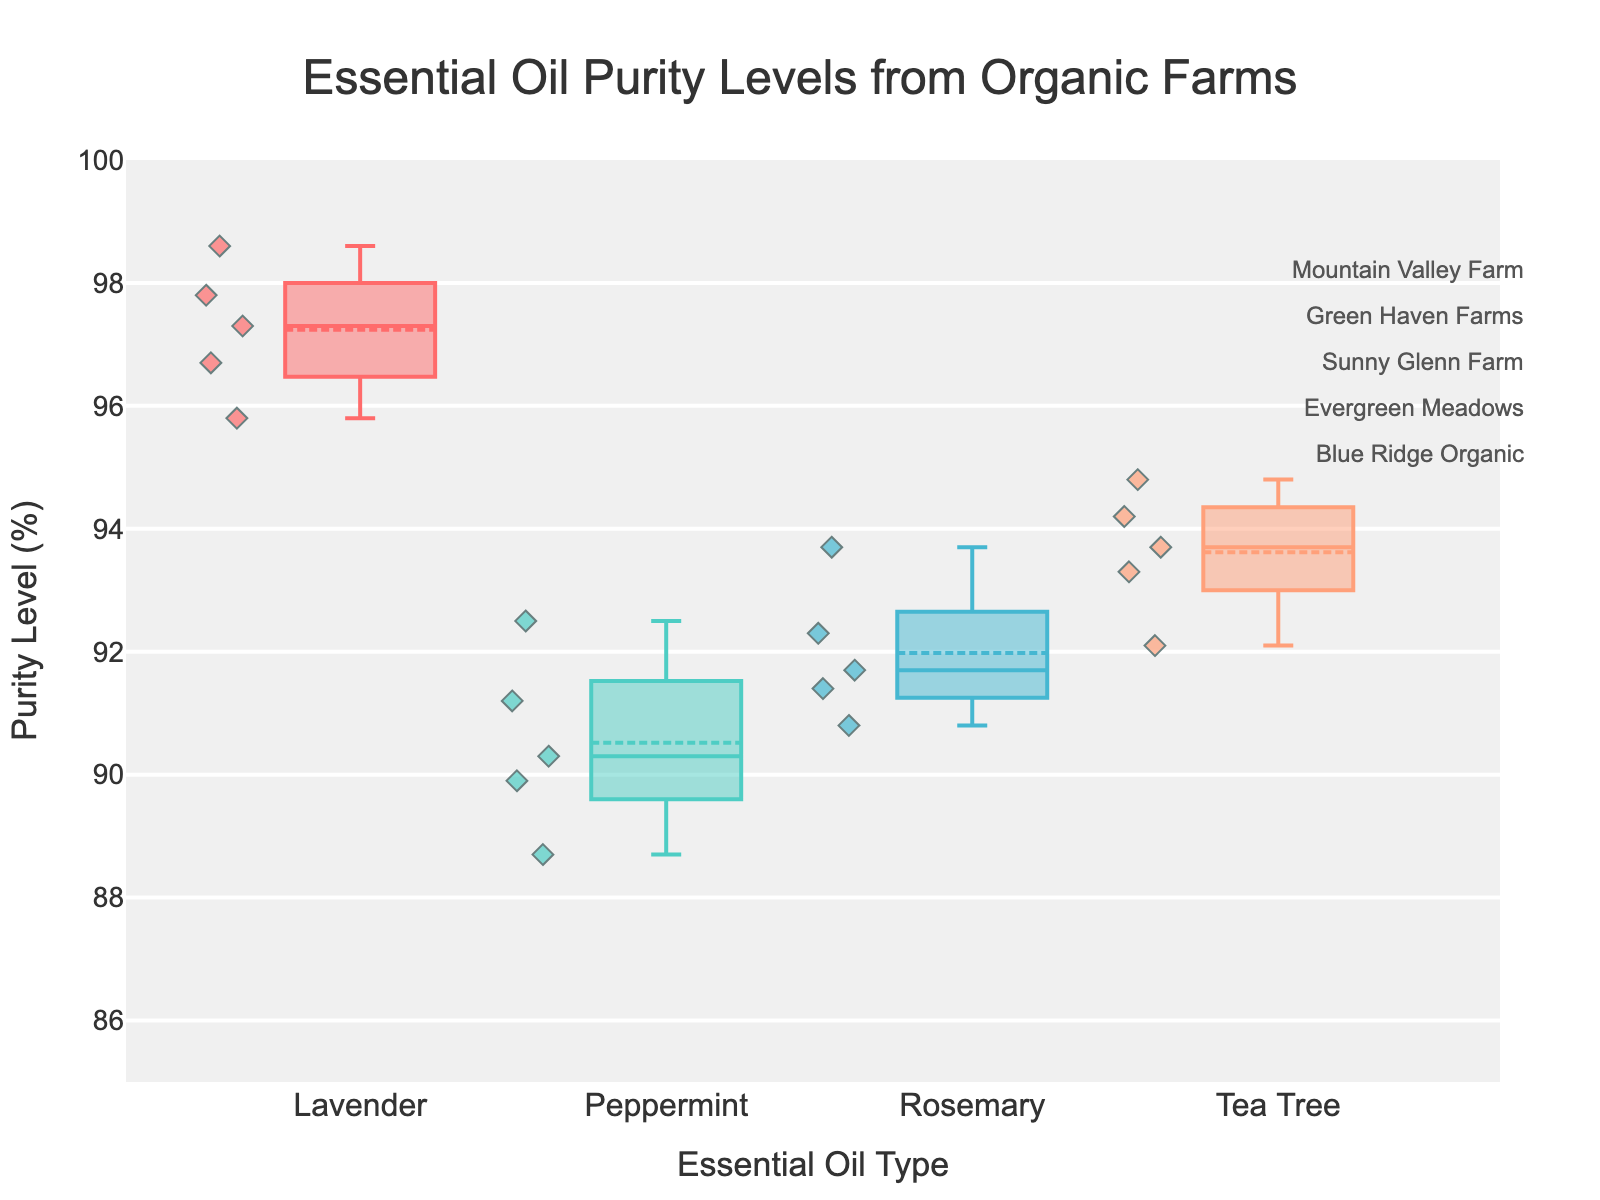What is the title of the figure? The title is usually displayed prominently at the top of the figure. It reads as, "Essential Oil Purity Levels from Organic Farms".
Answer: Essential Oil Purity Levels from Organic Farms What are the axis labels? The x-axis label typically describes the categories being compared, and the y-axis label describes the metric. The x-axis label is "Essential Oil Type", and the y-axis label is "Purity Level (%)".
Answer: Essential Oil Type, Purity Level (%) Which essential oil has the widest range in purity levels? To find the widest range, look for the essential oil with the largest distance between the box plot's whiskers. Peppermint shows the widest range of purity levels.
Answer: Peppermint What is the highest purity level for Tea Tree oil? Locate the maximum value of the scatter points for Tea Tree oil's box plot. The highest purity level for Tea Tree oil is 94.8.
Answer: 94.8 Which farm has the highest purity level for Lavender oil? Identify the scatter point with the highest value in the Lavender oil box plot and find its corresponding farm. Mountain Valley Farm has the highest purity level for Lavender oil at 98.6.
Answer: Mountain Valley Farm How does the median purity level of Lavender oil compare with that of Peppermint oil? Compare the horizontal line inside each box plot, representing the median. The median for Lavender oil is higher than that of Peppermint oil.
Answer: Lavender oil's median is higher What is the median purity level of Rosemary oil? Look at the horizontal line inside the box plot for Rosemary oil. The median purity level of Rosemary oil is 91.7.
Answer: 91.7 Which essential oil has the smallest interquartile range (IQR) in purity levels? The IQR is the distance between the first and third quartiles (the edges of the box). Identify the box with the smallest width. Tea Tree oil has the smallest IQR.
Answer: Tea Tree oil 